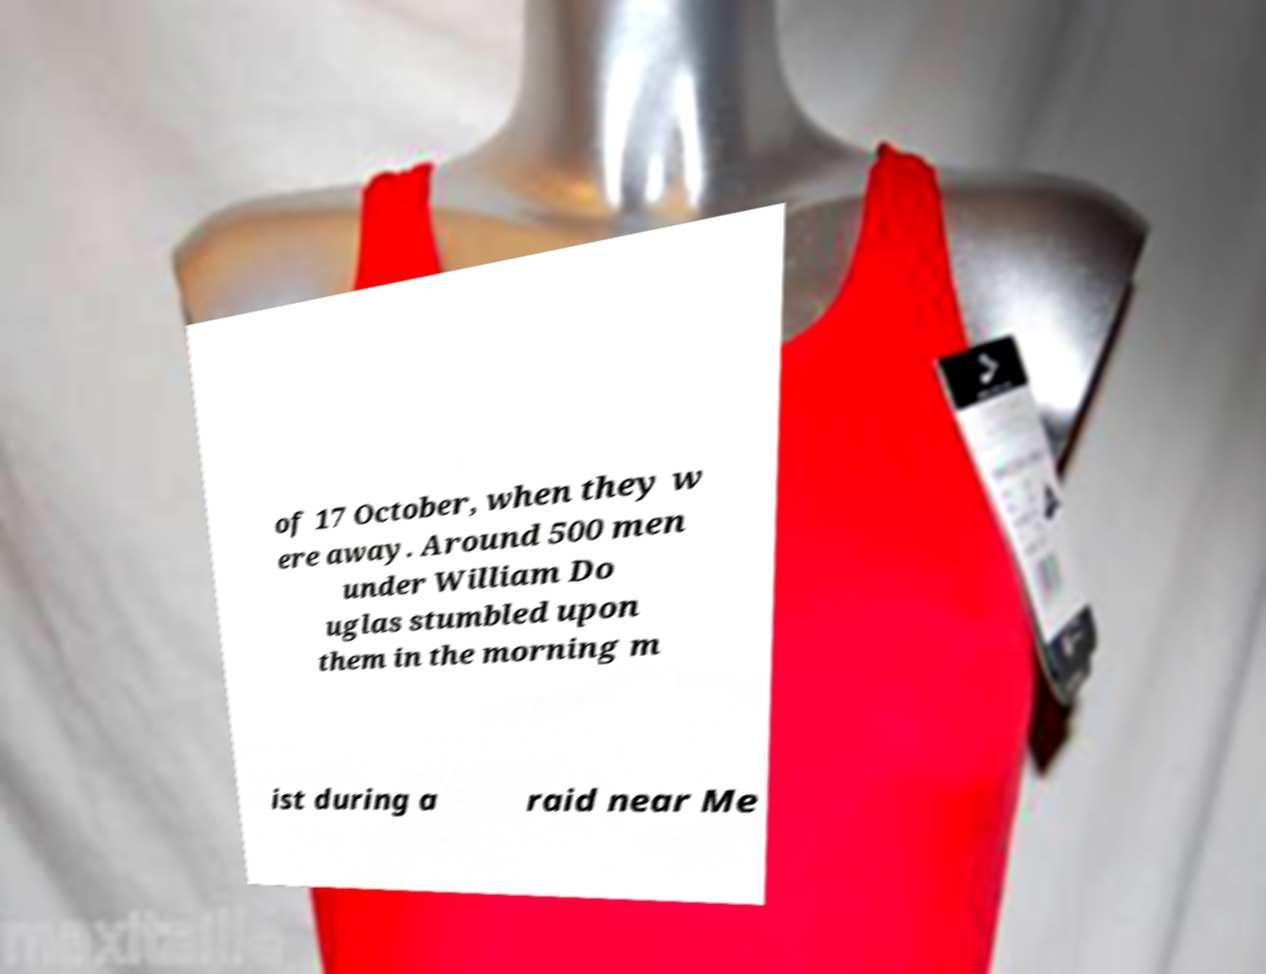Could you assist in decoding the text presented in this image and type it out clearly? of 17 October, when they w ere away. Around 500 men under William Do uglas stumbled upon them in the morning m ist during a raid near Me 